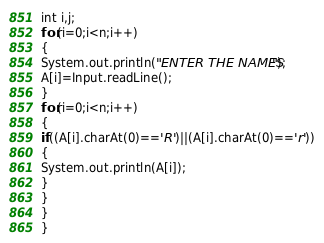Convert code to text. <code><loc_0><loc_0><loc_500><loc_500><_Java_>int i,j;
for(i=0;i<n;i++)
{
System.out.println("ENTER THE NAMES");
A[i]=Input.readLine();
}
for(i=0;i<n;i++)
{
if((A[i].charAt(0)=='R')||(A[i].charAt(0)=='r'))
{
System.out.println(A[i]);
}
}
}
}

</code> 